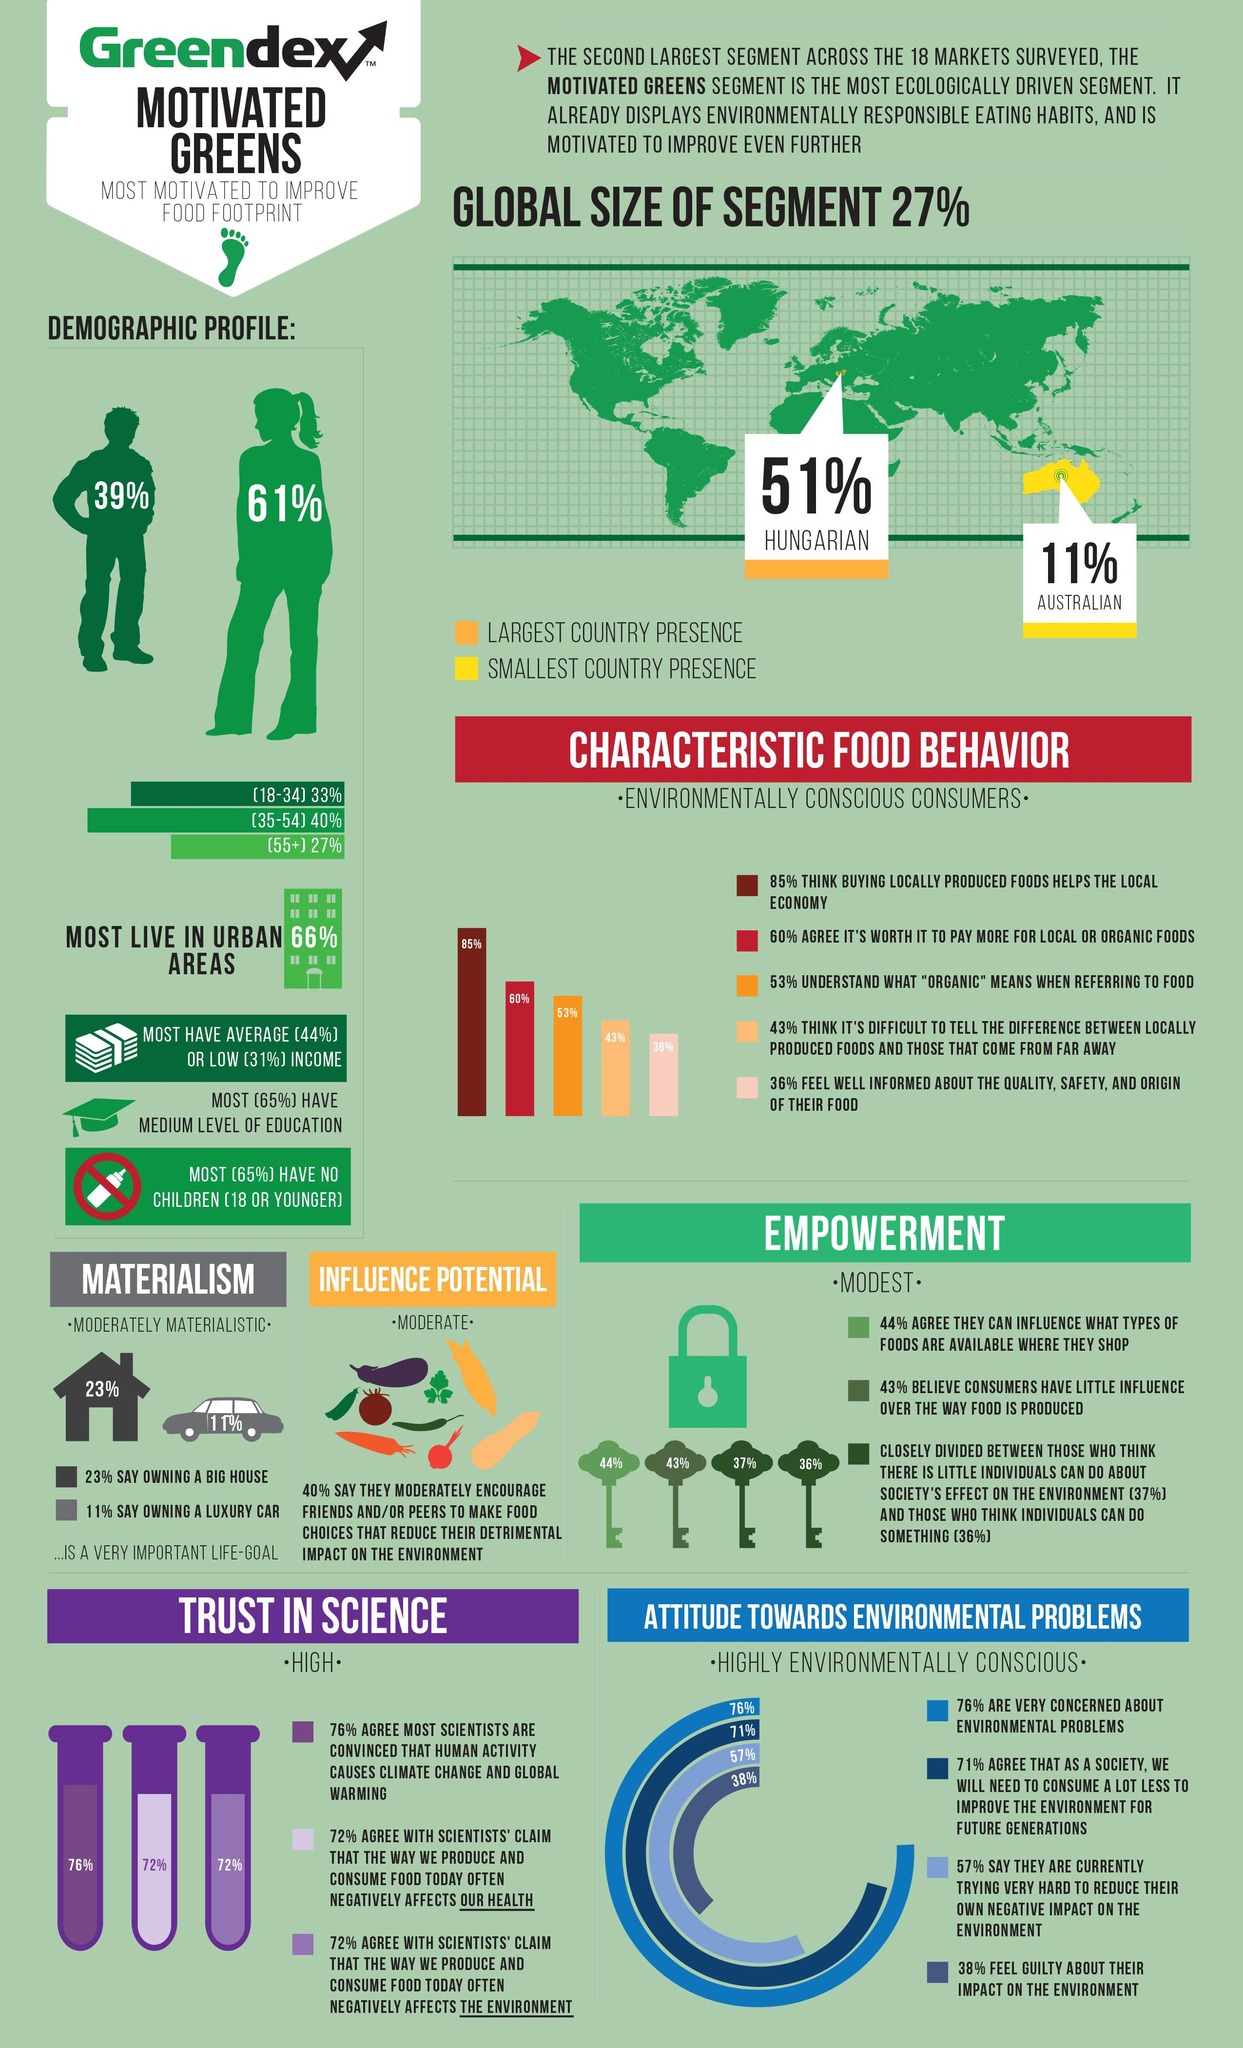Point out several critical features in this image. There are four keys depicted in this infographic. The infographic contains 9 vegetables. According to recent estimates, approximately 34% of the global population does not reside in urban areas. A significant percentage of individuals have high incomes, with 25% being a notable figure. Orange, yellow, and red are all colors that are commonly used to represent the country of Australia. However, the official national color of Australia is red. 